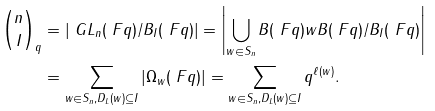Convert formula to latex. <formula><loc_0><loc_0><loc_500><loc_500>\binom { n } { I } _ { q } & = | \ G L _ { n } ( \ F q ) / B _ { I } ( \ F q ) | = \left | \bigcup _ { w \in S _ { n } } B ( \ F q ) w B ( \ F q ) / B _ { I } ( \ F q ) \right | \\ & = \sum _ { w \in S _ { n } , D _ { L } ( w ) \subseteq I } | \Omega _ { w } ( \ F q ) | = \sum _ { w \in S _ { n } , D _ { L } ( w ) \subseteq I } q ^ { \ell ( w ) } .</formula> 